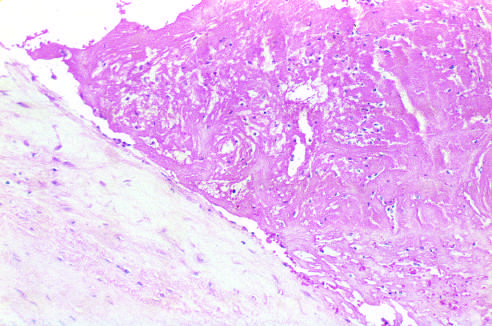what is only loosely attached to the cusp?
Answer the question using a single word or phrase. The thrombus 